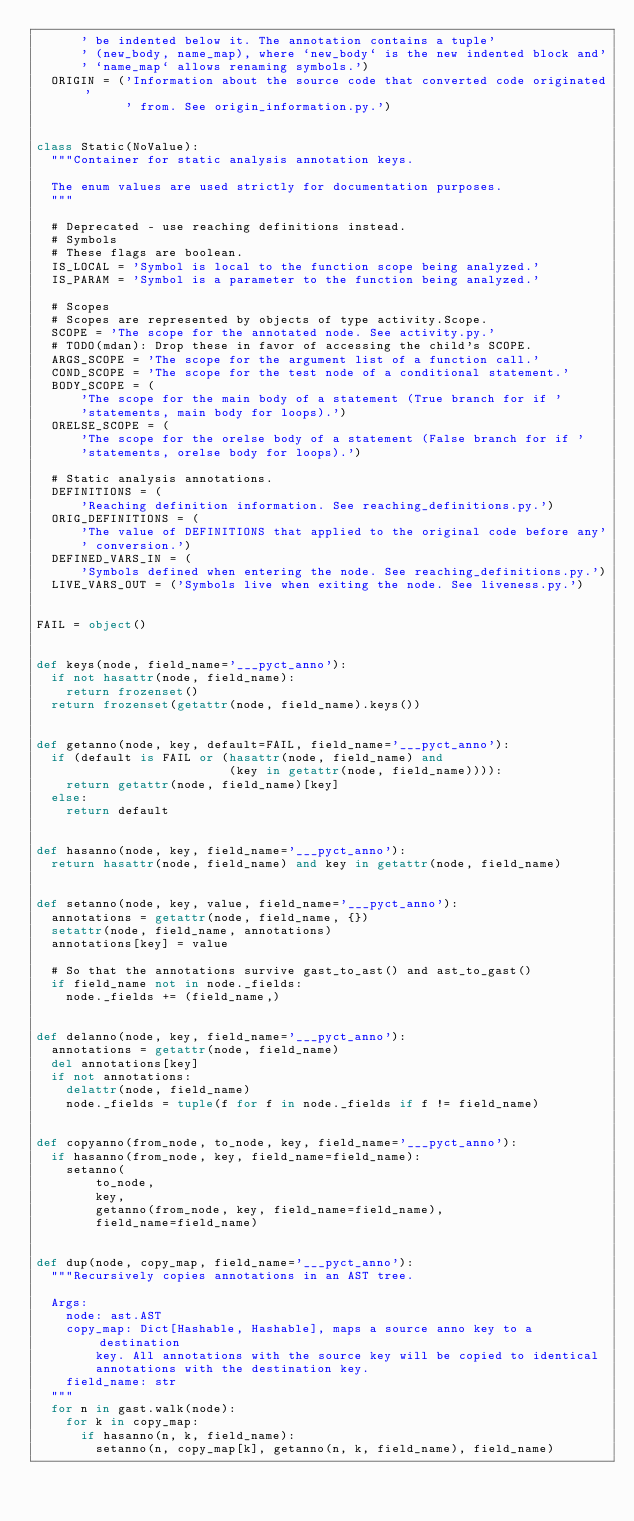<code> <loc_0><loc_0><loc_500><loc_500><_Python_>      ' be indented below it. The annotation contains a tuple'
      ' (new_body, name_map), where `new_body` is the new indented block and'
      ' `name_map` allows renaming symbols.')
  ORIGIN = ('Information about the source code that converted code originated'
            ' from. See origin_information.py.')


class Static(NoValue):
  """Container for static analysis annotation keys.

  The enum values are used strictly for documentation purposes.
  """

  # Deprecated - use reaching definitions instead.
  # Symbols
  # These flags are boolean.
  IS_LOCAL = 'Symbol is local to the function scope being analyzed.'
  IS_PARAM = 'Symbol is a parameter to the function being analyzed.'

  # Scopes
  # Scopes are represented by objects of type activity.Scope.
  SCOPE = 'The scope for the annotated node. See activity.py.'
  # TODO(mdan): Drop these in favor of accessing the child's SCOPE.
  ARGS_SCOPE = 'The scope for the argument list of a function call.'
  COND_SCOPE = 'The scope for the test node of a conditional statement.'
  BODY_SCOPE = (
      'The scope for the main body of a statement (True branch for if '
      'statements, main body for loops).')
  ORELSE_SCOPE = (
      'The scope for the orelse body of a statement (False branch for if '
      'statements, orelse body for loops).')

  # Static analysis annotations.
  DEFINITIONS = (
      'Reaching definition information. See reaching_definitions.py.')
  ORIG_DEFINITIONS = (
      'The value of DEFINITIONS that applied to the original code before any'
      ' conversion.')
  DEFINED_VARS_IN = (
      'Symbols defined when entering the node. See reaching_definitions.py.')
  LIVE_VARS_OUT = ('Symbols live when exiting the node. See liveness.py.')


FAIL = object()


def keys(node, field_name='___pyct_anno'):
  if not hasattr(node, field_name):
    return frozenset()
  return frozenset(getattr(node, field_name).keys())


def getanno(node, key, default=FAIL, field_name='___pyct_anno'):
  if (default is FAIL or (hasattr(node, field_name) and
                          (key in getattr(node, field_name)))):
    return getattr(node, field_name)[key]
  else:
    return default


def hasanno(node, key, field_name='___pyct_anno'):
  return hasattr(node, field_name) and key in getattr(node, field_name)


def setanno(node, key, value, field_name='___pyct_anno'):
  annotations = getattr(node, field_name, {})
  setattr(node, field_name, annotations)
  annotations[key] = value

  # So that the annotations survive gast_to_ast() and ast_to_gast()
  if field_name not in node._fields:
    node._fields += (field_name,)


def delanno(node, key, field_name='___pyct_anno'):
  annotations = getattr(node, field_name)
  del annotations[key]
  if not annotations:
    delattr(node, field_name)
    node._fields = tuple(f for f in node._fields if f != field_name)


def copyanno(from_node, to_node, key, field_name='___pyct_anno'):
  if hasanno(from_node, key, field_name=field_name):
    setanno(
        to_node,
        key,
        getanno(from_node, key, field_name=field_name),
        field_name=field_name)


def dup(node, copy_map, field_name='___pyct_anno'):
  """Recursively copies annotations in an AST tree.

  Args:
    node: ast.AST
    copy_map: Dict[Hashable, Hashable], maps a source anno key to a destination
        key. All annotations with the source key will be copied to identical
        annotations with the destination key.
    field_name: str
  """
  for n in gast.walk(node):
    for k in copy_map:
      if hasanno(n, k, field_name):
        setanno(n, copy_map[k], getanno(n, k, field_name), field_name)
</code> 